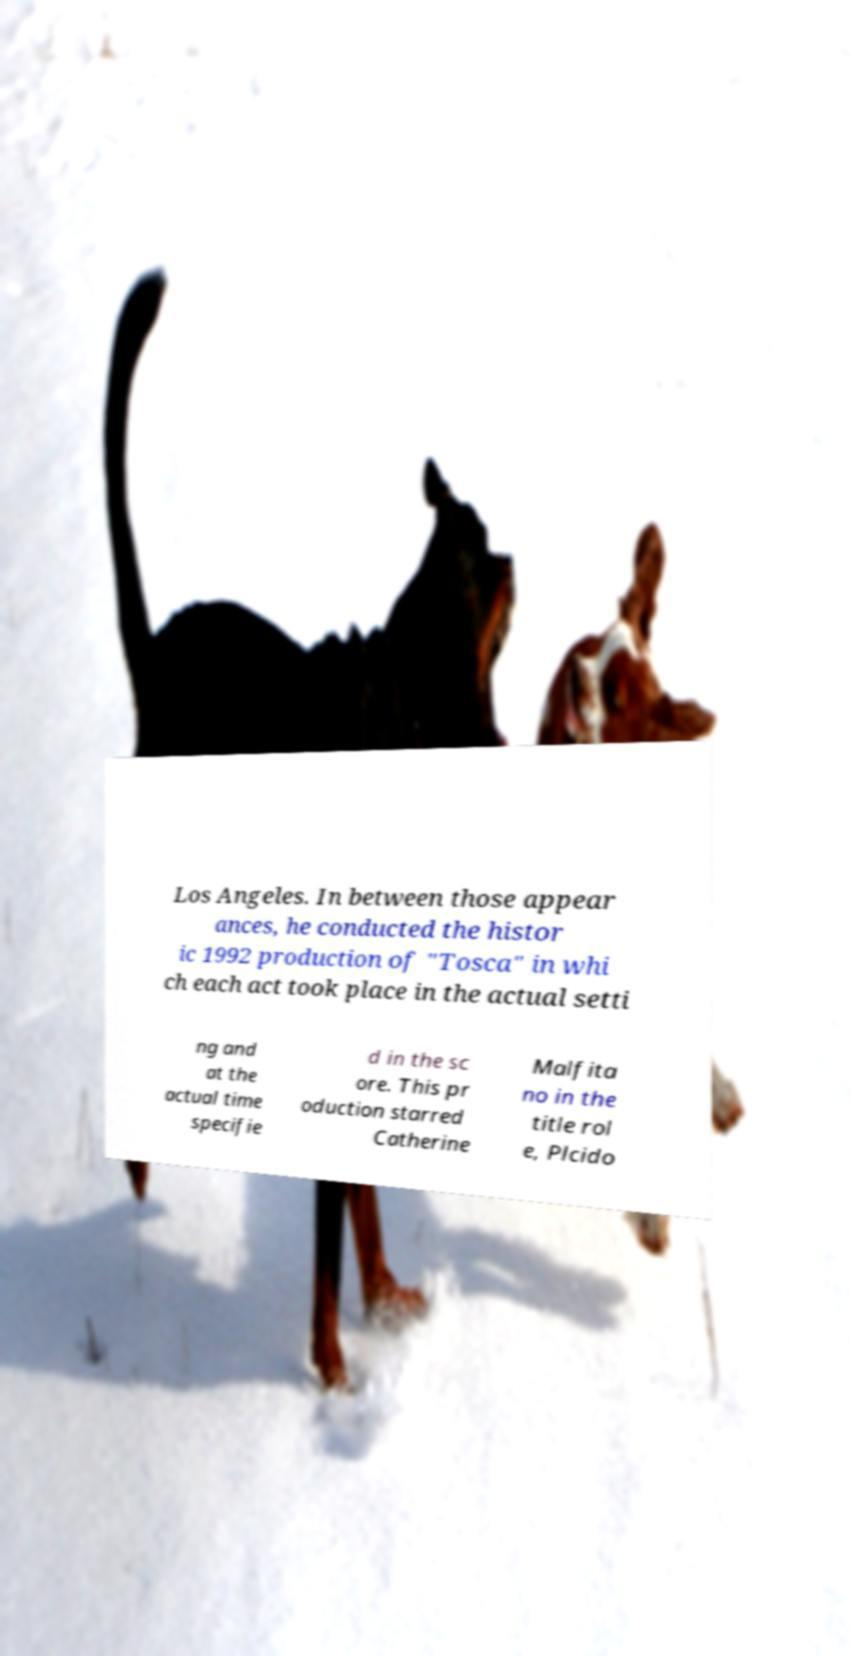Could you extract and type out the text from this image? Los Angeles. In between those appear ances, he conducted the histor ic 1992 production of "Tosca" in whi ch each act took place in the actual setti ng and at the actual time specifie d in the sc ore. This pr oduction starred Catherine Malfita no in the title rol e, Plcido 